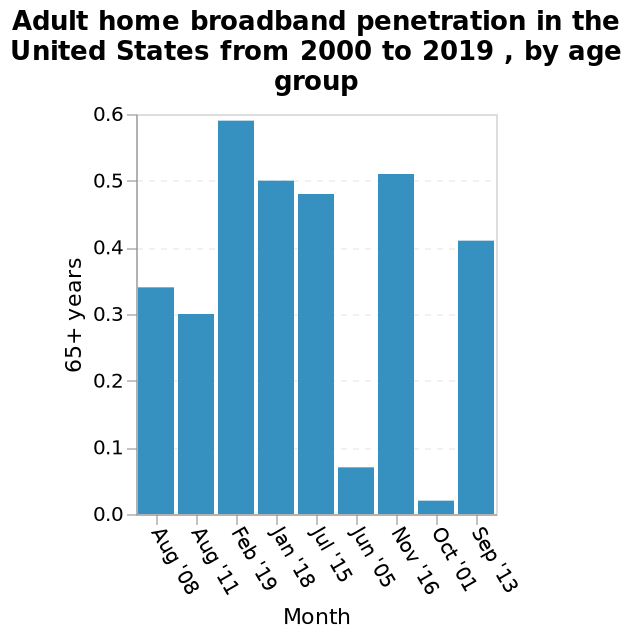<image>
What was the highest penetration of broadband with 65+ years?  The highest penetration of broadband with 65+ years was 0.59 on February 19th. How old were the individuals with the highest penetration of broadband?  The individuals with the highest penetration of broadband were 65+ years old. Which age group is marked on the y-axis as "65+ years"? The age group marked on the y-axis as "65+ years" corresponds to the penetration rate for adults aged 65 and above. What does the y-axis scale represent? The y-axis scale represents the Adult home broadband penetration rate. 